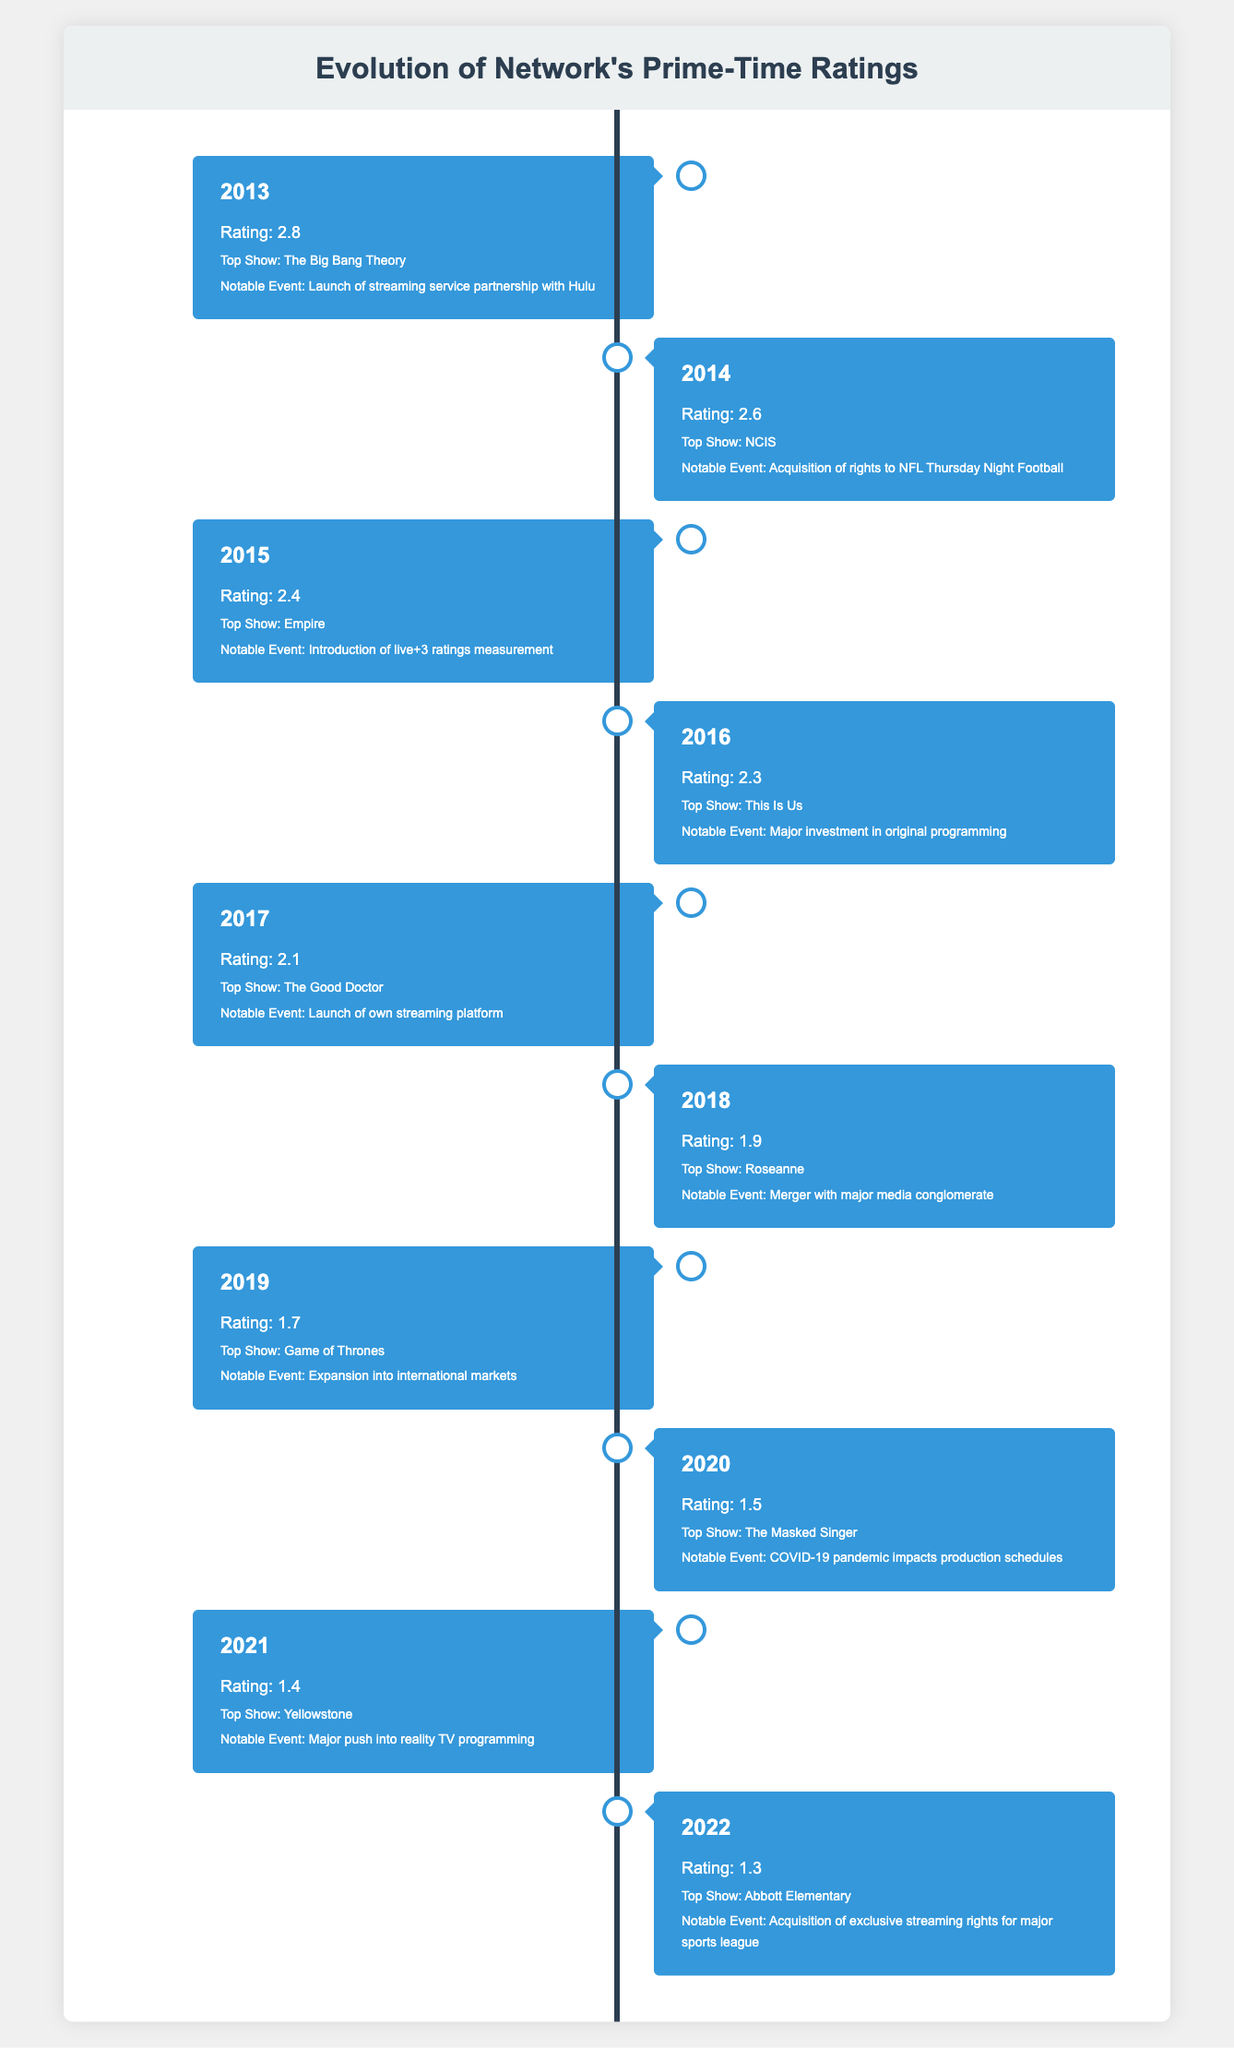What was the prime-time rating in 2013? The table shows that in 2013, the rating was 2.8.
Answer: 2.8 Which show had the highest rating in 2014? According to the table, the top show in 2014 was NCIS.
Answer: NCIS What is the difference in ratings between 2015 and 2016? The rating in 2015 was 2.4, and in 2016 it was 2.3. The difference is calculated as 2.4 - 2.3 = 0.1.
Answer: 0.1 Was there a notable event for the network in 2018? Yes, the notable event in 2018 was a merger with a major media conglomerate.
Answer: Yes What was the average prime-time rating over the decade? To find the average rating, sum all the ratings: (2.8 + 2.6 + 2.4 + 2.3 + 2.1 + 1.9 + 1.7 + 1.5 + 1.4 + 1.3) = 20.2. There are 10 data points, so the average is 20.2 / 10 = 2.02.
Answer: 2.02 Which top show had the lowest rating, and what was the rating? The lowest rating was in 2022 at 1.3, and the top show for that year was Abbott Elementary.
Answer: Abbott Elementary, 1.3 Did the network's ratings generally increase or decrease from 2013 to 2022? The ratings decreased from 2.8 in 2013 to 1.3 in 2022, indicating a downward trend.
Answer: Decrease What was the notable event in 2020, and what impact did it have? The notable event in 2020 was the COVID-19 pandemic impacting production schedules, which likely affected ratings and show availability.
Answer: COVID-19 pandemic impacts production schedules In which year did the network launch its own streaming platform? The network launched its own streaming platform in 2017, as mentioned in the notable event for that year.
Answer: 2017 